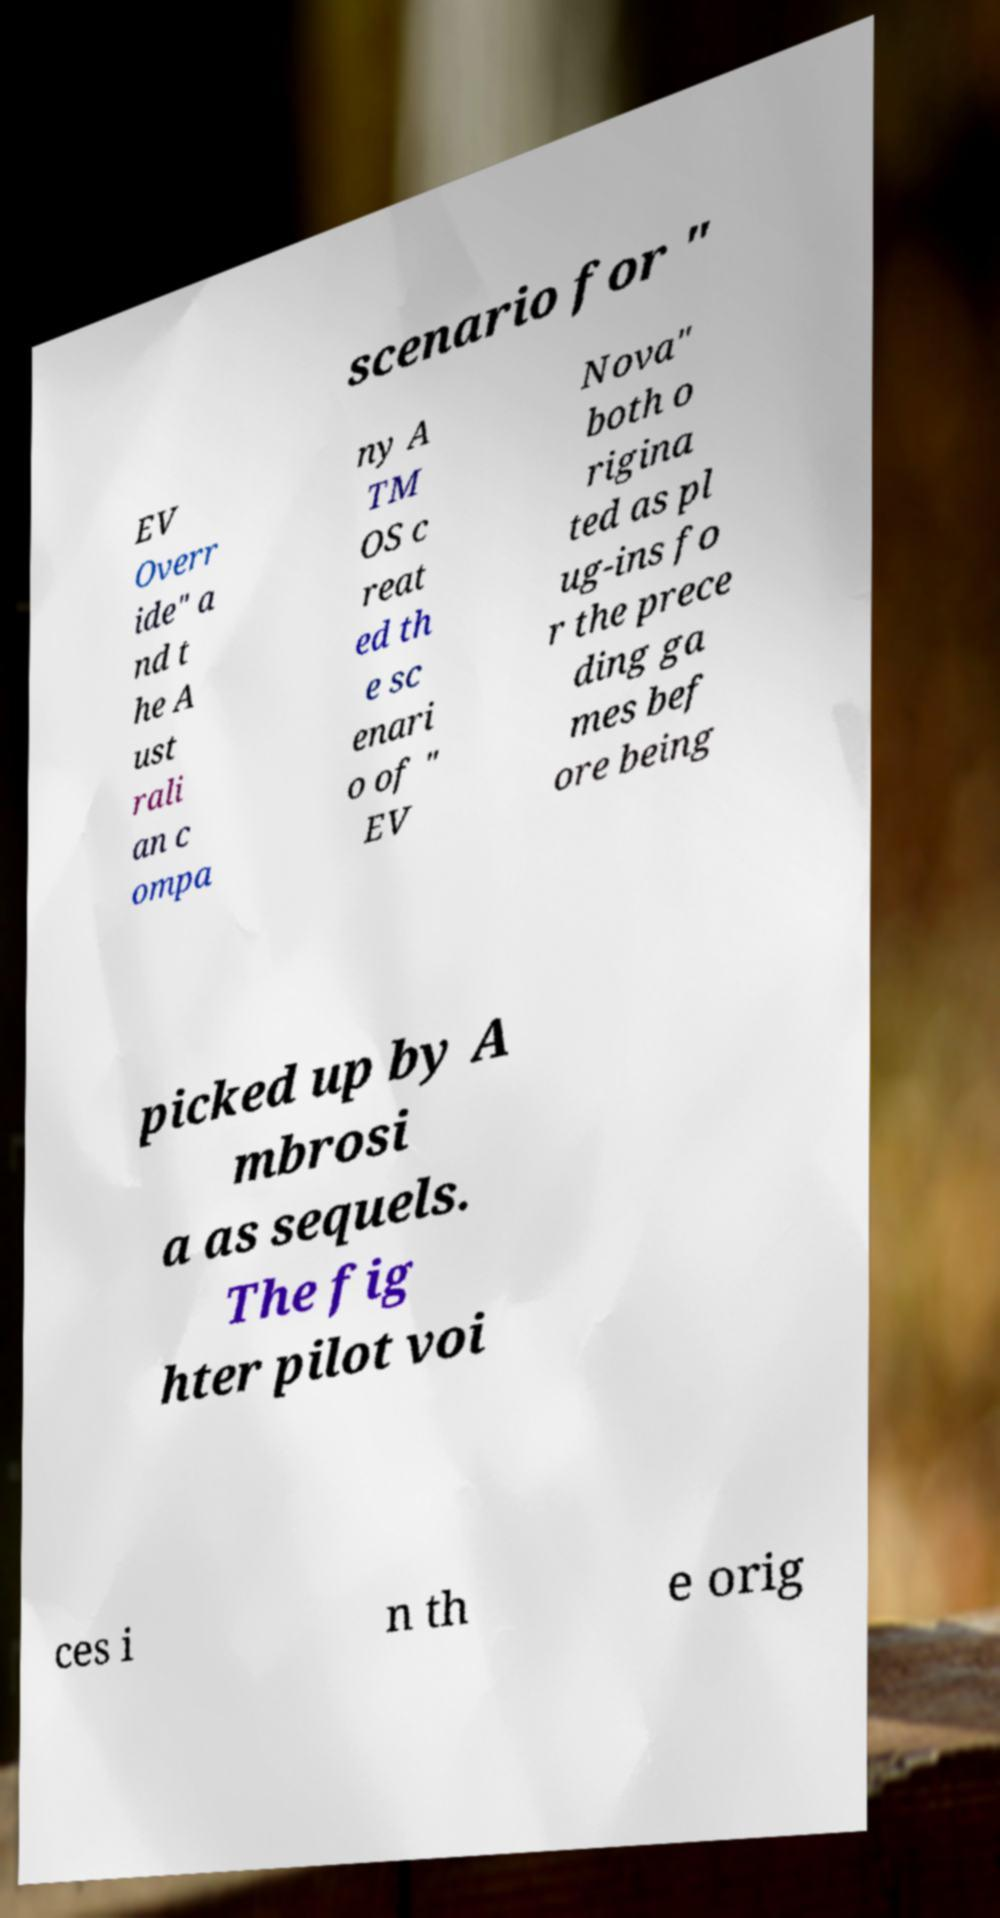Can you read and provide the text displayed in the image?This photo seems to have some interesting text. Can you extract and type it out for me? scenario for " EV Overr ide" a nd t he A ust rali an c ompa ny A TM OS c reat ed th e sc enari o of " EV Nova" both o rigina ted as pl ug-ins fo r the prece ding ga mes bef ore being picked up by A mbrosi a as sequels. The fig hter pilot voi ces i n th e orig 